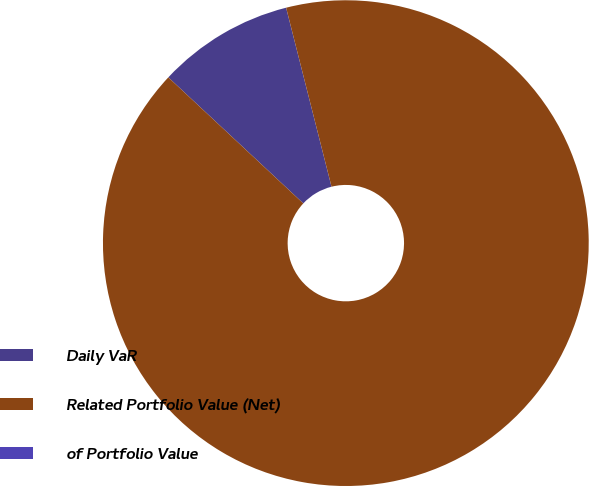Convert chart to OTSL. <chart><loc_0><loc_0><loc_500><loc_500><pie_chart><fcel>Daily VaR<fcel>Related Portfolio Value (Net)<fcel>of Portfolio Value<nl><fcel>9.09%<fcel>90.91%<fcel>0.0%<nl></chart> 